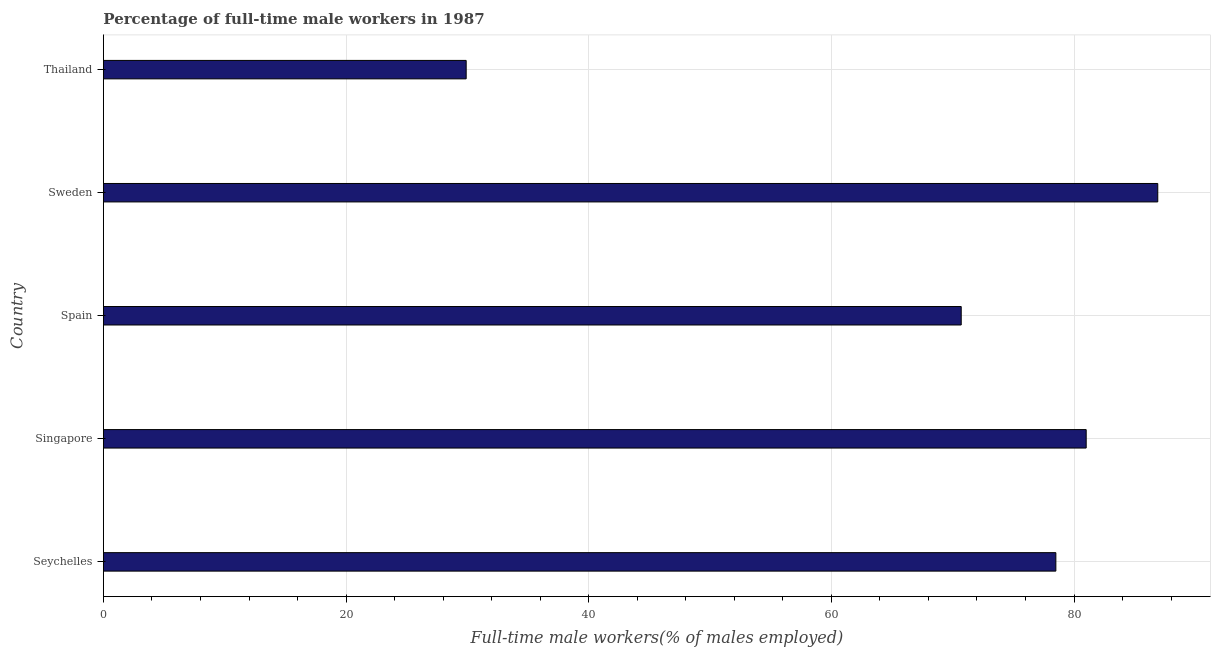What is the title of the graph?
Ensure brevity in your answer.  Percentage of full-time male workers in 1987. What is the label or title of the X-axis?
Offer a very short reply. Full-time male workers(% of males employed). What is the label or title of the Y-axis?
Give a very brief answer. Country. What is the percentage of full-time male workers in Seychelles?
Offer a terse response. 78.5. Across all countries, what is the maximum percentage of full-time male workers?
Keep it short and to the point. 86.9. Across all countries, what is the minimum percentage of full-time male workers?
Your answer should be very brief. 29.9. In which country was the percentage of full-time male workers minimum?
Keep it short and to the point. Thailand. What is the sum of the percentage of full-time male workers?
Offer a very short reply. 347. What is the difference between the percentage of full-time male workers in Spain and Thailand?
Provide a short and direct response. 40.8. What is the average percentage of full-time male workers per country?
Your response must be concise. 69.4. What is the median percentage of full-time male workers?
Make the answer very short. 78.5. What is the ratio of the percentage of full-time male workers in Spain to that in Sweden?
Your answer should be compact. 0.81. Is the difference between the percentage of full-time male workers in Spain and Thailand greater than the difference between any two countries?
Make the answer very short. No. How many bars are there?
Make the answer very short. 5. Are the values on the major ticks of X-axis written in scientific E-notation?
Make the answer very short. No. What is the Full-time male workers(% of males employed) in Seychelles?
Your answer should be compact. 78.5. What is the Full-time male workers(% of males employed) of Spain?
Offer a terse response. 70.7. What is the Full-time male workers(% of males employed) of Sweden?
Your answer should be very brief. 86.9. What is the Full-time male workers(% of males employed) in Thailand?
Provide a succinct answer. 29.9. What is the difference between the Full-time male workers(% of males employed) in Seychelles and Spain?
Provide a short and direct response. 7.8. What is the difference between the Full-time male workers(% of males employed) in Seychelles and Thailand?
Provide a short and direct response. 48.6. What is the difference between the Full-time male workers(% of males employed) in Singapore and Thailand?
Give a very brief answer. 51.1. What is the difference between the Full-time male workers(% of males employed) in Spain and Sweden?
Ensure brevity in your answer.  -16.2. What is the difference between the Full-time male workers(% of males employed) in Spain and Thailand?
Your answer should be very brief. 40.8. What is the difference between the Full-time male workers(% of males employed) in Sweden and Thailand?
Ensure brevity in your answer.  57. What is the ratio of the Full-time male workers(% of males employed) in Seychelles to that in Spain?
Your answer should be very brief. 1.11. What is the ratio of the Full-time male workers(% of males employed) in Seychelles to that in Sweden?
Your response must be concise. 0.9. What is the ratio of the Full-time male workers(% of males employed) in Seychelles to that in Thailand?
Your response must be concise. 2.62. What is the ratio of the Full-time male workers(% of males employed) in Singapore to that in Spain?
Your answer should be very brief. 1.15. What is the ratio of the Full-time male workers(% of males employed) in Singapore to that in Sweden?
Provide a short and direct response. 0.93. What is the ratio of the Full-time male workers(% of males employed) in Singapore to that in Thailand?
Your answer should be compact. 2.71. What is the ratio of the Full-time male workers(% of males employed) in Spain to that in Sweden?
Provide a succinct answer. 0.81. What is the ratio of the Full-time male workers(% of males employed) in Spain to that in Thailand?
Make the answer very short. 2.37. What is the ratio of the Full-time male workers(% of males employed) in Sweden to that in Thailand?
Ensure brevity in your answer.  2.91. 